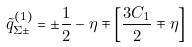<formula> <loc_0><loc_0><loc_500><loc_500>\tilde { q } ^ { ( 1 ) } _ { \Sigma \pm } = \pm \frac { 1 } { 2 } - \eta \mp \left [ \frac { 3 C _ { 1 } } { 2 } \mp \eta \right ]</formula> 